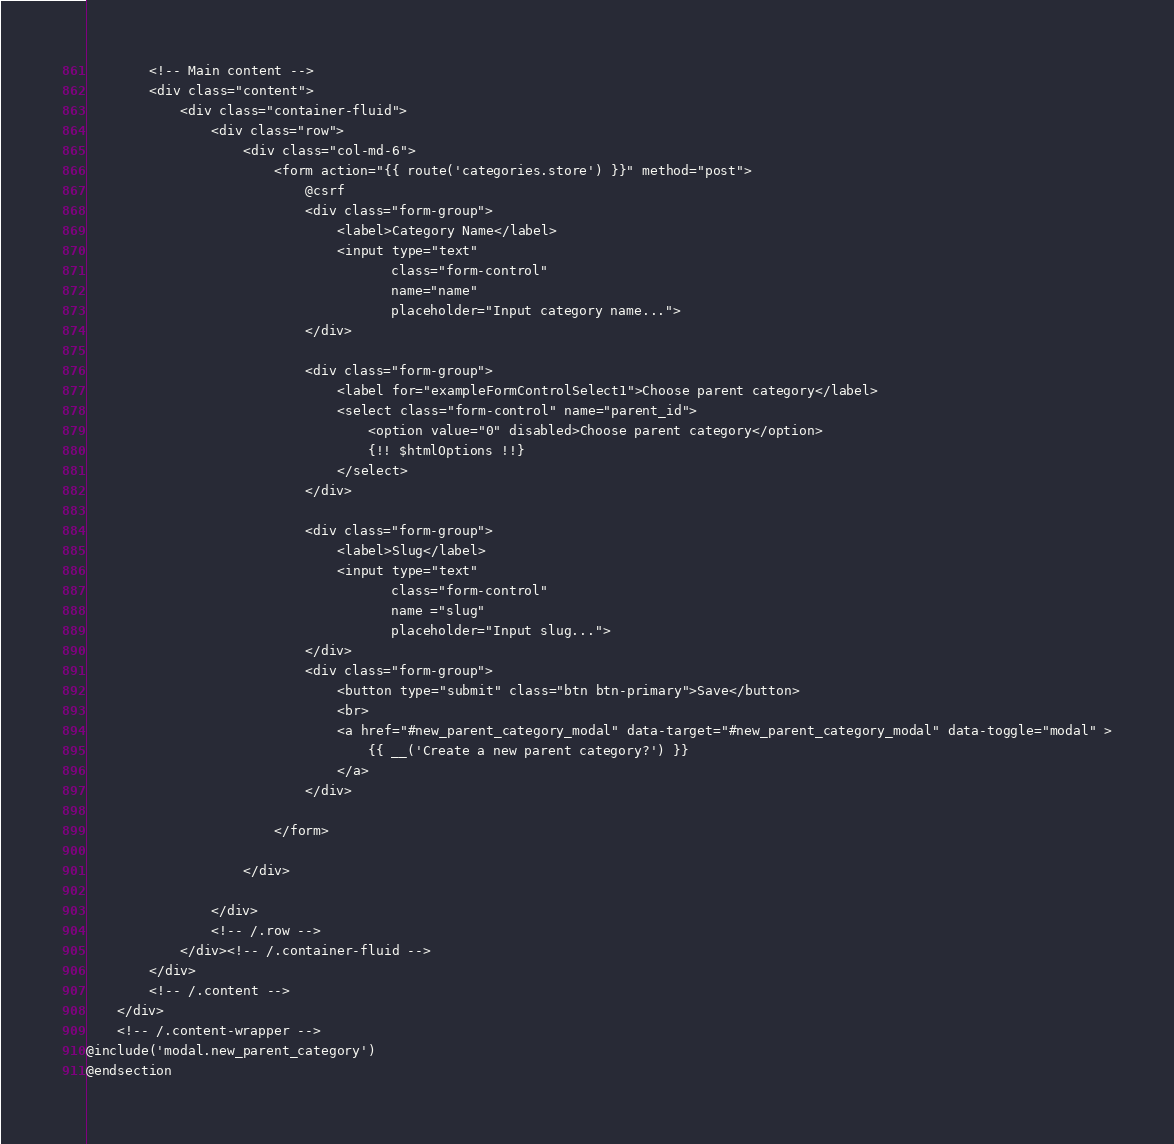Convert code to text. <code><loc_0><loc_0><loc_500><loc_500><_PHP_>
        <!-- Main content -->
        <div class="content">
            <div class="container-fluid">
                <div class="row">
                    <div class="col-md-6">
                        <form action="{{ route('categories.store') }}" method="post">
                            @csrf
                            <div class="form-group">
                                <label>Category Name</label>
                                <input type="text"
                                       class="form-control"
                                       name="name"
                                       placeholder="Input category name...">
                            </div>

                            <div class="form-group">
                                <label for="exampleFormControlSelect1">Choose parent category</label>
                                <select class="form-control" name="parent_id">
                                    <option value="0" disabled>Choose parent category</option>
                                    {!! $htmlOptions !!}
                                </select>
                            </div>

                            <div class="form-group">
                                <label>Slug</label>
                                <input type="text"
                                       class="form-control"
                                       name ="slug"
                                       placeholder="Input slug...">
                            </div>
                            <div class="form-group">
                                <button type="submit" class="btn btn-primary">Save</button>
                                <br>
                                <a href="#new_parent_category_modal" data-target="#new_parent_category_modal" data-toggle="modal" >
                                    {{ __('Create a new parent category?') }}
                                </a>
                            </div>

                        </form>

                    </div>

                </div>
                <!-- /.row -->
            </div><!-- /.container-fluid -->
        </div>
        <!-- /.content -->
    </div>
    <!-- /.content-wrapper -->
@include('modal.new_parent_category')
@endsection
</code> 